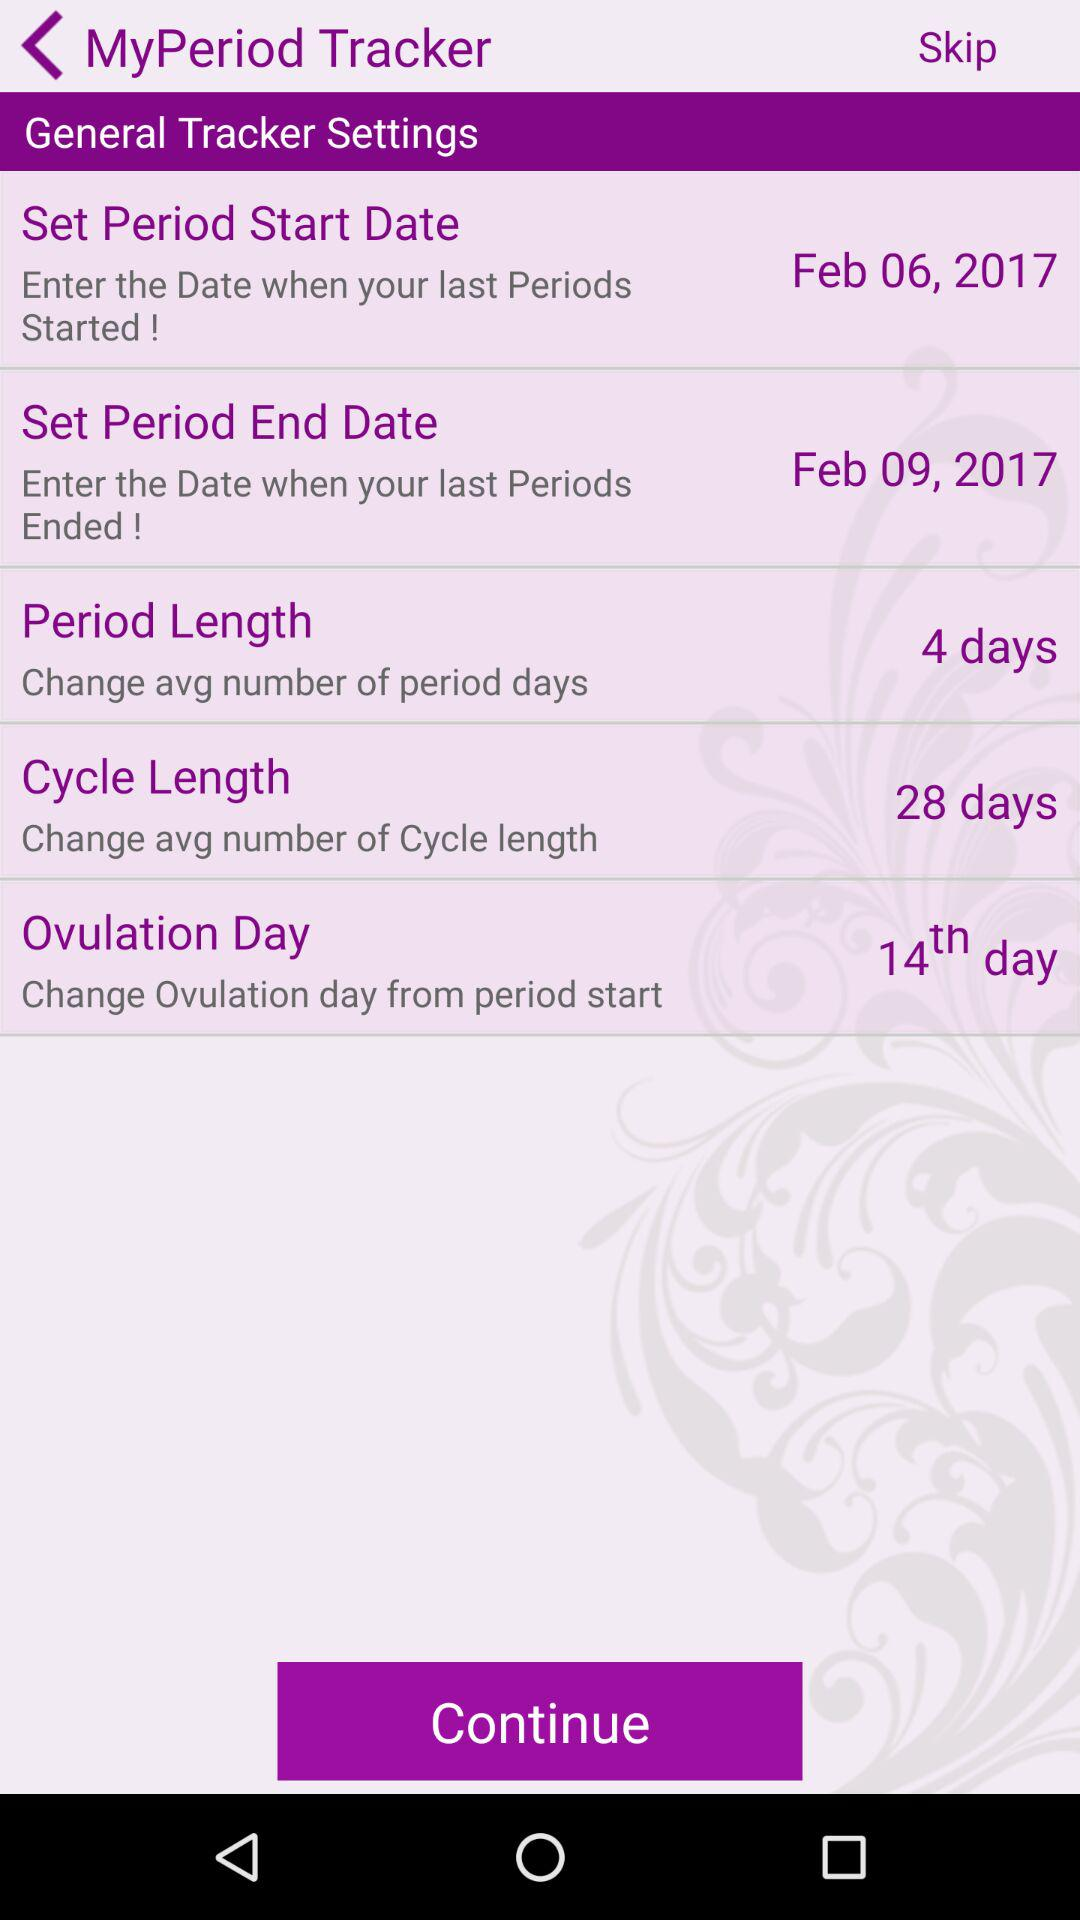What is the period length? The period length is 4 days. 